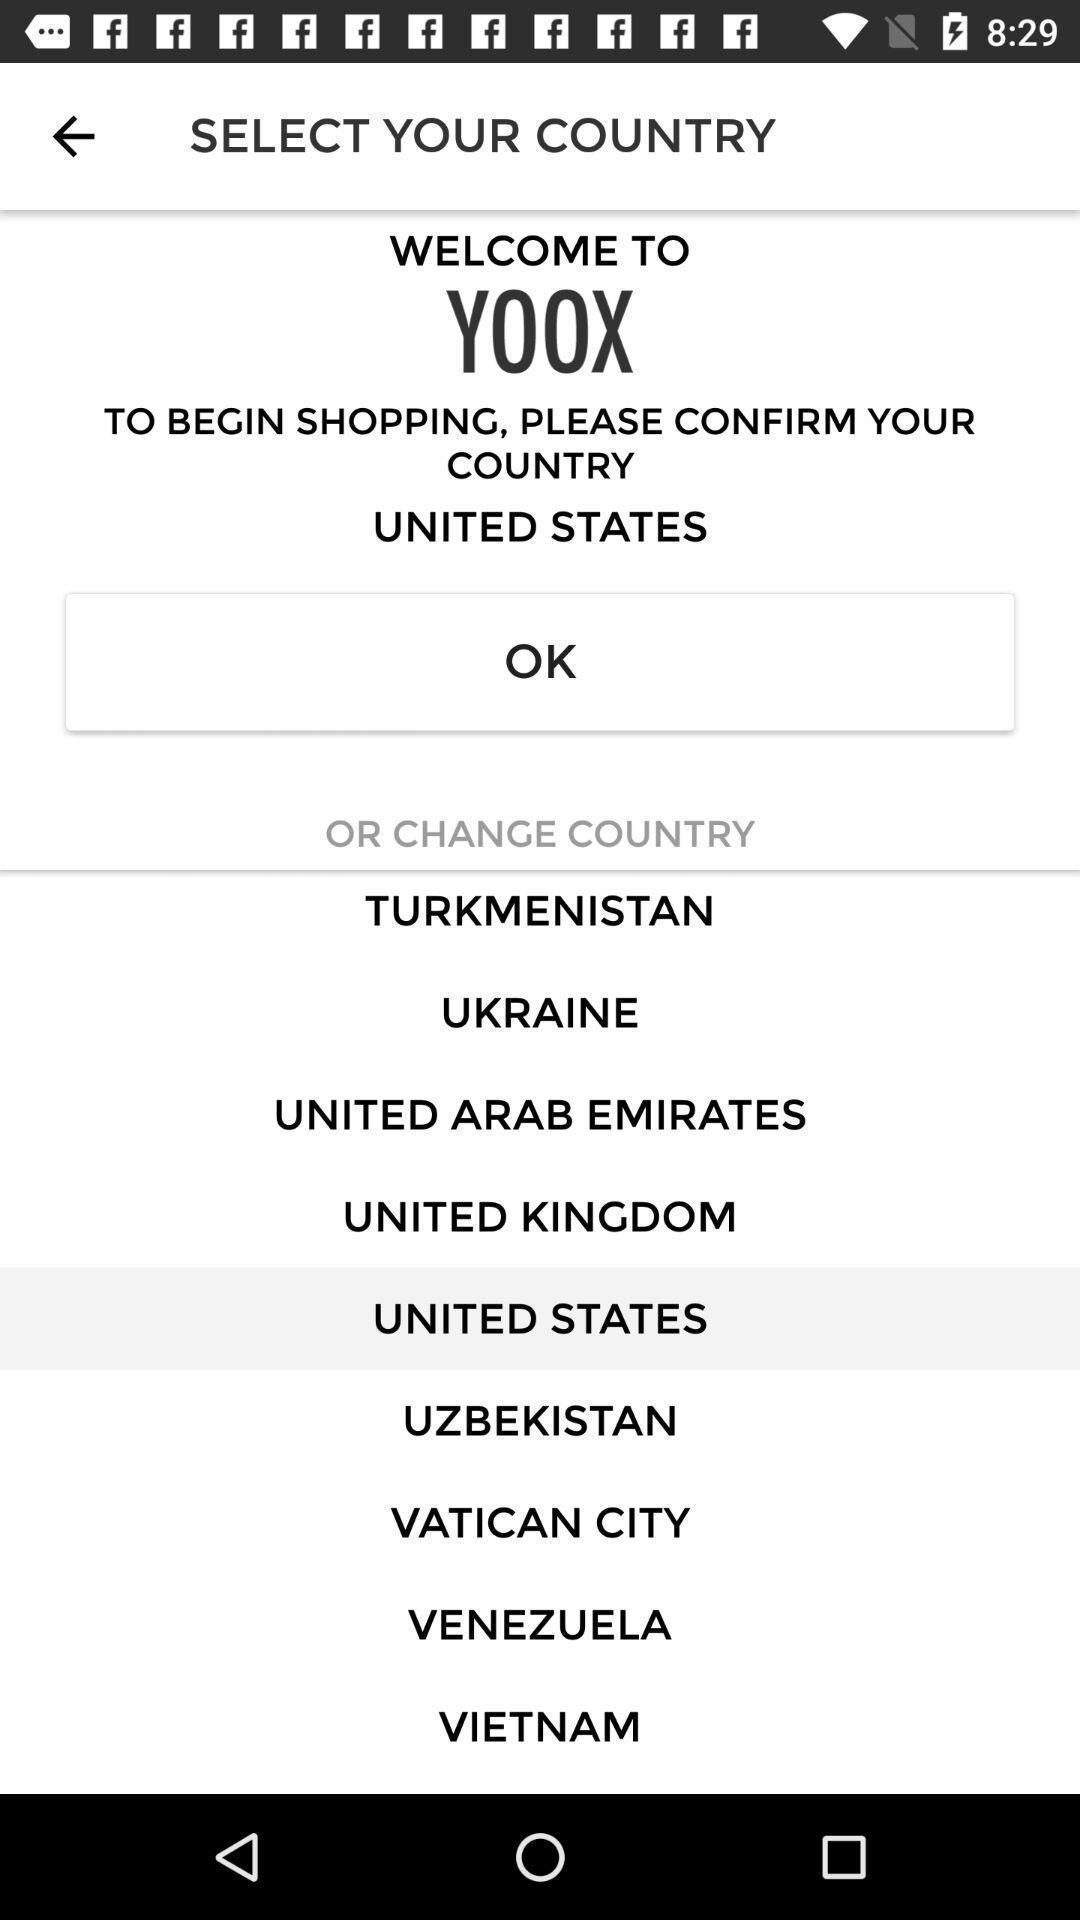What is the overall content of this screenshot? Shopping app asking to select a country. 